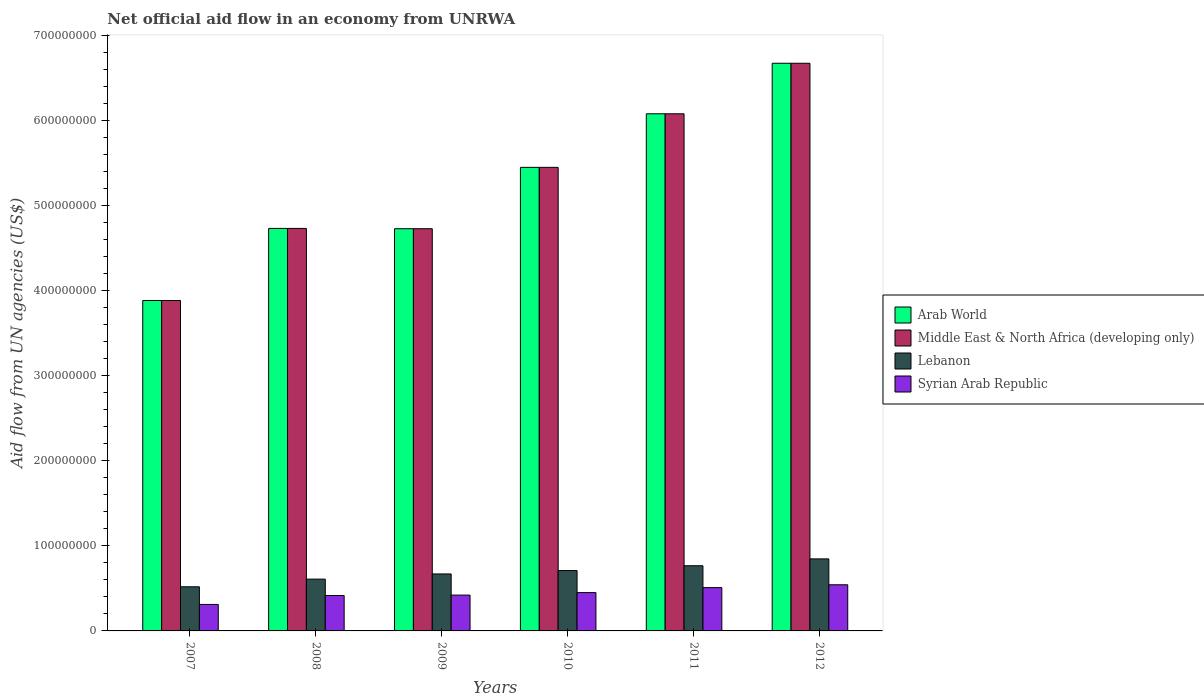How many different coloured bars are there?
Make the answer very short. 4. How many groups of bars are there?
Your answer should be compact. 6. Are the number of bars per tick equal to the number of legend labels?
Your answer should be very brief. Yes. Are the number of bars on each tick of the X-axis equal?
Provide a short and direct response. Yes. What is the label of the 3rd group of bars from the left?
Offer a terse response. 2009. In how many cases, is the number of bars for a given year not equal to the number of legend labels?
Provide a succinct answer. 0. What is the net official aid flow in Arab World in 2008?
Your response must be concise. 4.73e+08. Across all years, what is the maximum net official aid flow in Syrian Arab Republic?
Keep it short and to the point. 5.42e+07. Across all years, what is the minimum net official aid flow in Lebanon?
Your response must be concise. 5.19e+07. In which year was the net official aid flow in Syrian Arab Republic minimum?
Keep it short and to the point. 2007. What is the total net official aid flow in Arab World in the graph?
Ensure brevity in your answer.  3.15e+09. What is the difference between the net official aid flow in Arab World in 2009 and that in 2011?
Your answer should be very brief. -1.35e+08. What is the difference between the net official aid flow in Syrian Arab Republic in 2011 and the net official aid flow in Lebanon in 2008?
Offer a terse response. -1.00e+07. What is the average net official aid flow in Lebanon per year?
Provide a short and direct response. 6.87e+07. In the year 2007, what is the difference between the net official aid flow in Lebanon and net official aid flow in Arab World?
Give a very brief answer. -3.37e+08. In how many years, is the net official aid flow in Arab World greater than 340000000 US$?
Ensure brevity in your answer.  6. What is the ratio of the net official aid flow in Arab World in 2010 to that in 2012?
Provide a short and direct response. 0.82. Is the net official aid flow in Middle East & North Africa (developing only) in 2007 less than that in 2010?
Give a very brief answer. Yes. Is the difference between the net official aid flow in Lebanon in 2010 and 2011 greater than the difference between the net official aid flow in Arab World in 2010 and 2011?
Keep it short and to the point. Yes. What is the difference between the highest and the second highest net official aid flow in Syrian Arab Republic?
Give a very brief answer. 3.35e+06. What is the difference between the highest and the lowest net official aid flow in Middle East & North Africa (developing only)?
Ensure brevity in your answer.  2.79e+08. Is it the case that in every year, the sum of the net official aid flow in Arab World and net official aid flow in Lebanon is greater than the sum of net official aid flow in Middle East & North Africa (developing only) and net official aid flow in Syrian Arab Republic?
Offer a very short reply. No. What does the 3rd bar from the left in 2008 represents?
Your answer should be compact. Lebanon. What does the 3rd bar from the right in 2012 represents?
Ensure brevity in your answer.  Middle East & North Africa (developing only). How many bars are there?
Your answer should be compact. 24. Are all the bars in the graph horizontal?
Your response must be concise. No. How many years are there in the graph?
Provide a short and direct response. 6. Does the graph contain any zero values?
Your response must be concise. No. What is the title of the graph?
Ensure brevity in your answer.  Net official aid flow in an economy from UNRWA. Does "Cambodia" appear as one of the legend labels in the graph?
Your answer should be very brief. No. What is the label or title of the X-axis?
Your answer should be compact. Years. What is the label or title of the Y-axis?
Provide a succinct answer. Aid flow from UN agencies (US$). What is the Aid flow from UN agencies (US$) in Arab World in 2007?
Make the answer very short. 3.88e+08. What is the Aid flow from UN agencies (US$) of Middle East & North Africa (developing only) in 2007?
Ensure brevity in your answer.  3.88e+08. What is the Aid flow from UN agencies (US$) in Lebanon in 2007?
Your answer should be very brief. 5.19e+07. What is the Aid flow from UN agencies (US$) in Syrian Arab Republic in 2007?
Provide a short and direct response. 3.12e+07. What is the Aid flow from UN agencies (US$) of Arab World in 2008?
Provide a succinct answer. 4.73e+08. What is the Aid flow from UN agencies (US$) in Middle East & North Africa (developing only) in 2008?
Provide a short and direct response. 4.73e+08. What is the Aid flow from UN agencies (US$) of Lebanon in 2008?
Make the answer very short. 6.09e+07. What is the Aid flow from UN agencies (US$) of Syrian Arab Republic in 2008?
Ensure brevity in your answer.  4.16e+07. What is the Aid flow from UN agencies (US$) of Arab World in 2009?
Your response must be concise. 4.73e+08. What is the Aid flow from UN agencies (US$) of Middle East & North Africa (developing only) in 2009?
Your response must be concise. 4.73e+08. What is the Aid flow from UN agencies (US$) of Lebanon in 2009?
Keep it short and to the point. 6.70e+07. What is the Aid flow from UN agencies (US$) in Syrian Arab Republic in 2009?
Your answer should be compact. 4.21e+07. What is the Aid flow from UN agencies (US$) in Arab World in 2010?
Offer a terse response. 5.45e+08. What is the Aid flow from UN agencies (US$) in Middle East & North Africa (developing only) in 2010?
Your answer should be very brief. 5.45e+08. What is the Aid flow from UN agencies (US$) of Lebanon in 2010?
Offer a terse response. 7.10e+07. What is the Aid flow from UN agencies (US$) in Syrian Arab Republic in 2010?
Give a very brief answer. 4.50e+07. What is the Aid flow from UN agencies (US$) in Arab World in 2011?
Your answer should be very brief. 6.08e+08. What is the Aid flow from UN agencies (US$) in Middle East & North Africa (developing only) in 2011?
Keep it short and to the point. 6.08e+08. What is the Aid flow from UN agencies (US$) in Lebanon in 2011?
Your response must be concise. 7.66e+07. What is the Aid flow from UN agencies (US$) in Syrian Arab Republic in 2011?
Provide a succinct answer. 5.09e+07. What is the Aid flow from UN agencies (US$) in Arab World in 2012?
Keep it short and to the point. 6.67e+08. What is the Aid flow from UN agencies (US$) of Middle East & North Africa (developing only) in 2012?
Make the answer very short. 6.67e+08. What is the Aid flow from UN agencies (US$) of Lebanon in 2012?
Offer a very short reply. 8.47e+07. What is the Aid flow from UN agencies (US$) of Syrian Arab Republic in 2012?
Give a very brief answer. 5.42e+07. Across all years, what is the maximum Aid flow from UN agencies (US$) in Arab World?
Offer a terse response. 6.67e+08. Across all years, what is the maximum Aid flow from UN agencies (US$) of Middle East & North Africa (developing only)?
Your response must be concise. 6.67e+08. Across all years, what is the maximum Aid flow from UN agencies (US$) of Lebanon?
Give a very brief answer. 8.47e+07. Across all years, what is the maximum Aid flow from UN agencies (US$) of Syrian Arab Republic?
Make the answer very short. 5.42e+07. Across all years, what is the minimum Aid flow from UN agencies (US$) of Arab World?
Your answer should be compact. 3.88e+08. Across all years, what is the minimum Aid flow from UN agencies (US$) of Middle East & North Africa (developing only)?
Make the answer very short. 3.88e+08. Across all years, what is the minimum Aid flow from UN agencies (US$) in Lebanon?
Your response must be concise. 5.19e+07. Across all years, what is the minimum Aid flow from UN agencies (US$) of Syrian Arab Republic?
Make the answer very short. 3.12e+07. What is the total Aid flow from UN agencies (US$) of Arab World in the graph?
Ensure brevity in your answer.  3.15e+09. What is the total Aid flow from UN agencies (US$) in Middle East & North Africa (developing only) in the graph?
Offer a terse response. 3.15e+09. What is the total Aid flow from UN agencies (US$) of Lebanon in the graph?
Give a very brief answer. 4.12e+08. What is the total Aid flow from UN agencies (US$) of Syrian Arab Republic in the graph?
Offer a very short reply. 2.65e+08. What is the difference between the Aid flow from UN agencies (US$) of Arab World in 2007 and that in 2008?
Provide a succinct answer. -8.48e+07. What is the difference between the Aid flow from UN agencies (US$) in Middle East & North Africa (developing only) in 2007 and that in 2008?
Offer a terse response. -8.48e+07. What is the difference between the Aid flow from UN agencies (US$) in Lebanon in 2007 and that in 2008?
Your answer should be very brief. -9.01e+06. What is the difference between the Aid flow from UN agencies (US$) of Syrian Arab Republic in 2007 and that in 2008?
Offer a very short reply. -1.05e+07. What is the difference between the Aid flow from UN agencies (US$) of Arab World in 2007 and that in 2009?
Your response must be concise. -8.44e+07. What is the difference between the Aid flow from UN agencies (US$) of Middle East & North Africa (developing only) in 2007 and that in 2009?
Provide a short and direct response. -8.44e+07. What is the difference between the Aid flow from UN agencies (US$) of Lebanon in 2007 and that in 2009?
Your response must be concise. -1.51e+07. What is the difference between the Aid flow from UN agencies (US$) of Syrian Arab Republic in 2007 and that in 2009?
Provide a succinct answer. -1.10e+07. What is the difference between the Aid flow from UN agencies (US$) of Arab World in 2007 and that in 2010?
Ensure brevity in your answer.  -1.57e+08. What is the difference between the Aid flow from UN agencies (US$) in Middle East & North Africa (developing only) in 2007 and that in 2010?
Offer a terse response. -1.57e+08. What is the difference between the Aid flow from UN agencies (US$) of Lebanon in 2007 and that in 2010?
Keep it short and to the point. -1.91e+07. What is the difference between the Aid flow from UN agencies (US$) in Syrian Arab Republic in 2007 and that in 2010?
Make the answer very short. -1.39e+07. What is the difference between the Aid flow from UN agencies (US$) of Arab World in 2007 and that in 2011?
Provide a succinct answer. -2.20e+08. What is the difference between the Aid flow from UN agencies (US$) of Middle East & North Africa (developing only) in 2007 and that in 2011?
Your answer should be very brief. -2.20e+08. What is the difference between the Aid flow from UN agencies (US$) in Lebanon in 2007 and that in 2011?
Ensure brevity in your answer.  -2.47e+07. What is the difference between the Aid flow from UN agencies (US$) of Syrian Arab Republic in 2007 and that in 2011?
Your response must be concise. -1.98e+07. What is the difference between the Aid flow from UN agencies (US$) in Arab World in 2007 and that in 2012?
Provide a short and direct response. -2.79e+08. What is the difference between the Aid flow from UN agencies (US$) in Middle East & North Africa (developing only) in 2007 and that in 2012?
Provide a succinct answer. -2.79e+08. What is the difference between the Aid flow from UN agencies (US$) in Lebanon in 2007 and that in 2012?
Provide a succinct answer. -3.28e+07. What is the difference between the Aid flow from UN agencies (US$) in Syrian Arab Republic in 2007 and that in 2012?
Offer a very short reply. -2.31e+07. What is the difference between the Aid flow from UN agencies (US$) in Arab World in 2008 and that in 2009?
Offer a terse response. 3.60e+05. What is the difference between the Aid flow from UN agencies (US$) in Middle East & North Africa (developing only) in 2008 and that in 2009?
Your response must be concise. 3.60e+05. What is the difference between the Aid flow from UN agencies (US$) in Lebanon in 2008 and that in 2009?
Your answer should be very brief. -6.08e+06. What is the difference between the Aid flow from UN agencies (US$) in Syrian Arab Republic in 2008 and that in 2009?
Your response must be concise. -4.90e+05. What is the difference between the Aid flow from UN agencies (US$) in Arab World in 2008 and that in 2010?
Provide a succinct answer. -7.18e+07. What is the difference between the Aid flow from UN agencies (US$) in Middle East & North Africa (developing only) in 2008 and that in 2010?
Your response must be concise. -7.18e+07. What is the difference between the Aid flow from UN agencies (US$) of Lebanon in 2008 and that in 2010?
Keep it short and to the point. -1.01e+07. What is the difference between the Aid flow from UN agencies (US$) in Syrian Arab Republic in 2008 and that in 2010?
Offer a very short reply. -3.40e+06. What is the difference between the Aid flow from UN agencies (US$) in Arab World in 2008 and that in 2011?
Offer a very short reply. -1.35e+08. What is the difference between the Aid flow from UN agencies (US$) in Middle East & North Africa (developing only) in 2008 and that in 2011?
Make the answer very short. -1.35e+08. What is the difference between the Aid flow from UN agencies (US$) of Lebanon in 2008 and that in 2011?
Provide a succinct answer. -1.57e+07. What is the difference between the Aid flow from UN agencies (US$) of Syrian Arab Republic in 2008 and that in 2011?
Provide a short and direct response. -9.26e+06. What is the difference between the Aid flow from UN agencies (US$) in Arab World in 2008 and that in 2012?
Your answer should be very brief. -1.94e+08. What is the difference between the Aid flow from UN agencies (US$) of Middle East & North Africa (developing only) in 2008 and that in 2012?
Give a very brief answer. -1.94e+08. What is the difference between the Aid flow from UN agencies (US$) in Lebanon in 2008 and that in 2012?
Provide a succinct answer. -2.38e+07. What is the difference between the Aid flow from UN agencies (US$) in Syrian Arab Republic in 2008 and that in 2012?
Provide a succinct answer. -1.26e+07. What is the difference between the Aid flow from UN agencies (US$) of Arab World in 2009 and that in 2010?
Offer a very short reply. -7.21e+07. What is the difference between the Aid flow from UN agencies (US$) of Middle East & North Africa (developing only) in 2009 and that in 2010?
Ensure brevity in your answer.  -7.21e+07. What is the difference between the Aid flow from UN agencies (US$) in Lebanon in 2009 and that in 2010?
Your response must be concise. -3.99e+06. What is the difference between the Aid flow from UN agencies (US$) of Syrian Arab Republic in 2009 and that in 2010?
Provide a succinct answer. -2.91e+06. What is the difference between the Aid flow from UN agencies (US$) of Arab World in 2009 and that in 2011?
Make the answer very short. -1.35e+08. What is the difference between the Aid flow from UN agencies (US$) in Middle East & North Africa (developing only) in 2009 and that in 2011?
Give a very brief answer. -1.35e+08. What is the difference between the Aid flow from UN agencies (US$) in Lebanon in 2009 and that in 2011?
Your answer should be very brief. -9.64e+06. What is the difference between the Aid flow from UN agencies (US$) in Syrian Arab Republic in 2009 and that in 2011?
Keep it short and to the point. -8.77e+06. What is the difference between the Aid flow from UN agencies (US$) of Arab World in 2009 and that in 2012?
Your answer should be very brief. -1.95e+08. What is the difference between the Aid flow from UN agencies (US$) of Middle East & North Africa (developing only) in 2009 and that in 2012?
Provide a succinct answer. -1.95e+08. What is the difference between the Aid flow from UN agencies (US$) of Lebanon in 2009 and that in 2012?
Your answer should be compact. -1.77e+07. What is the difference between the Aid flow from UN agencies (US$) in Syrian Arab Republic in 2009 and that in 2012?
Ensure brevity in your answer.  -1.21e+07. What is the difference between the Aid flow from UN agencies (US$) in Arab World in 2010 and that in 2011?
Offer a terse response. -6.30e+07. What is the difference between the Aid flow from UN agencies (US$) of Middle East & North Africa (developing only) in 2010 and that in 2011?
Ensure brevity in your answer.  -6.30e+07. What is the difference between the Aid flow from UN agencies (US$) in Lebanon in 2010 and that in 2011?
Make the answer very short. -5.65e+06. What is the difference between the Aid flow from UN agencies (US$) of Syrian Arab Republic in 2010 and that in 2011?
Provide a succinct answer. -5.86e+06. What is the difference between the Aid flow from UN agencies (US$) in Arab World in 2010 and that in 2012?
Offer a very short reply. -1.22e+08. What is the difference between the Aid flow from UN agencies (US$) in Middle East & North Africa (developing only) in 2010 and that in 2012?
Ensure brevity in your answer.  -1.22e+08. What is the difference between the Aid flow from UN agencies (US$) of Lebanon in 2010 and that in 2012?
Your answer should be compact. -1.37e+07. What is the difference between the Aid flow from UN agencies (US$) of Syrian Arab Republic in 2010 and that in 2012?
Your answer should be compact. -9.21e+06. What is the difference between the Aid flow from UN agencies (US$) of Arab World in 2011 and that in 2012?
Offer a very short reply. -5.94e+07. What is the difference between the Aid flow from UN agencies (US$) of Middle East & North Africa (developing only) in 2011 and that in 2012?
Keep it short and to the point. -5.94e+07. What is the difference between the Aid flow from UN agencies (US$) in Lebanon in 2011 and that in 2012?
Provide a succinct answer. -8.07e+06. What is the difference between the Aid flow from UN agencies (US$) of Syrian Arab Republic in 2011 and that in 2012?
Your answer should be compact. -3.35e+06. What is the difference between the Aid flow from UN agencies (US$) of Arab World in 2007 and the Aid flow from UN agencies (US$) of Middle East & North Africa (developing only) in 2008?
Keep it short and to the point. -8.48e+07. What is the difference between the Aid flow from UN agencies (US$) in Arab World in 2007 and the Aid flow from UN agencies (US$) in Lebanon in 2008?
Your answer should be very brief. 3.28e+08. What is the difference between the Aid flow from UN agencies (US$) in Arab World in 2007 and the Aid flow from UN agencies (US$) in Syrian Arab Republic in 2008?
Provide a succinct answer. 3.47e+08. What is the difference between the Aid flow from UN agencies (US$) of Middle East & North Africa (developing only) in 2007 and the Aid flow from UN agencies (US$) of Lebanon in 2008?
Give a very brief answer. 3.28e+08. What is the difference between the Aid flow from UN agencies (US$) in Middle East & North Africa (developing only) in 2007 and the Aid flow from UN agencies (US$) in Syrian Arab Republic in 2008?
Provide a succinct answer. 3.47e+08. What is the difference between the Aid flow from UN agencies (US$) in Lebanon in 2007 and the Aid flow from UN agencies (US$) in Syrian Arab Republic in 2008?
Keep it short and to the point. 1.02e+07. What is the difference between the Aid flow from UN agencies (US$) in Arab World in 2007 and the Aid flow from UN agencies (US$) in Middle East & North Africa (developing only) in 2009?
Provide a short and direct response. -8.44e+07. What is the difference between the Aid flow from UN agencies (US$) of Arab World in 2007 and the Aid flow from UN agencies (US$) of Lebanon in 2009?
Your answer should be compact. 3.21e+08. What is the difference between the Aid flow from UN agencies (US$) in Arab World in 2007 and the Aid flow from UN agencies (US$) in Syrian Arab Republic in 2009?
Give a very brief answer. 3.46e+08. What is the difference between the Aid flow from UN agencies (US$) in Middle East & North Africa (developing only) in 2007 and the Aid flow from UN agencies (US$) in Lebanon in 2009?
Your answer should be very brief. 3.21e+08. What is the difference between the Aid flow from UN agencies (US$) of Middle East & North Africa (developing only) in 2007 and the Aid flow from UN agencies (US$) of Syrian Arab Republic in 2009?
Offer a very short reply. 3.46e+08. What is the difference between the Aid flow from UN agencies (US$) in Lebanon in 2007 and the Aid flow from UN agencies (US$) in Syrian Arab Republic in 2009?
Make the answer very short. 9.76e+06. What is the difference between the Aid flow from UN agencies (US$) in Arab World in 2007 and the Aid flow from UN agencies (US$) in Middle East & North Africa (developing only) in 2010?
Offer a very short reply. -1.57e+08. What is the difference between the Aid flow from UN agencies (US$) in Arab World in 2007 and the Aid flow from UN agencies (US$) in Lebanon in 2010?
Your answer should be very brief. 3.17e+08. What is the difference between the Aid flow from UN agencies (US$) of Arab World in 2007 and the Aid flow from UN agencies (US$) of Syrian Arab Republic in 2010?
Keep it short and to the point. 3.43e+08. What is the difference between the Aid flow from UN agencies (US$) in Middle East & North Africa (developing only) in 2007 and the Aid flow from UN agencies (US$) in Lebanon in 2010?
Ensure brevity in your answer.  3.17e+08. What is the difference between the Aid flow from UN agencies (US$) of Middle East & North Africa (developing only) in 2007 and the Aid flow from UN agencies (US$) of Syrian Arab Republic in 2010?
Offer a very short reply. 3.43e+08. What is the difference between the Aid flow from UN agencies (US$) of Lebanon in 2007 and the Aid flow from UN agencies (US$) of Syrian Arab Republic in 2010?
Your response must be concise. 6.85e+06. What is the difference between the Aid flow from UN agencies (US$) in Arab World in 2007 and the Aid flow from UN agencies (US$) in Middle East & North Africa (developing only) in 2011?
Offer a terse response. -2.20e+08. What is the difference between the Aid flow from UN agencies (US$) in Arab World in 2007 and the Aid flow from UN agencies (US$) in Lebanon in 2011?
Ensure brevity in your answer.  3.12e+08. What is the difference between the Aid flow from UN agencies (US$) of Arab World in 2007 and the Aid flow from UN agencies (US$) of Syrian Arab Republic in 2011?
Ensure brevity in your answer.  3.38e+08. What is the difference between the Aid flow from UN agencies (US$) of Middle East & North Africa (developing only) in 2007 and the Aid flow from UN agencies (US$) of Lebanon in 2011?
Keep it short and to the point. 3.12e+08. What is the difference between the Aid flow from UN agencies (US$) of Middle East & North Africa (developing only) in 2007 and the Aid flow from UN agencies (US$) of Syrian Arab Republic in 2011?
Your response must be concise. 3.38e+08. What is the difference between the Aid flow from UN agencies (US$) in Lebanon in 2007 and the Aid flow from UN agencies (US$) in Syrian Arab Republic in 2011?
Provide a short and direct response. 9.90e+05. What is the difference between the Aid flow from UN agencies (US$) in Arab World in 2007 and the Aid flow from UN agencies (US$) in Middle East & North Africa (developing only) in 2012?
Keep it short and to the point. -2.79e+08. What is the difference between the Aid flow from UN agencies (US$) of Arab World in 2007 and the Aid flow from UN agencies (US$) of Lebanon in 2012?
Your response must be concise. 3.04e+08. What is the difference between the Aid flow from UN agencies (US$) in Arab World in 2007 and the Aid flow from UN agencies (US$) in Syrian Arab Republic in 2012?
Keep it short and to the point. 3.34e+08. What is the difference between the Aid flow from UN agencies (US$) in Middle East & North Africa (developing only) in 2007 and the Aid flow from UN agencies (US$) in Lebanon in 2012?
Offer a terse response. 3.04e+08. What is the difference between the Aid flow from UN agencies (US$) of Middle East & North Africa (developing only) in 2007 and the Aid flow from UN agencies (US$) of Syrian Arab Republic in 2012?
Keep it short and to the point. 3.34e+08. What is the difference between the Aid flow from UN agencies (US$) of Lebanon in 2007 and the Aid flow from UN agencies (US$) of Syrian Arab Republic in 2012?
Make the answer very short. -2.36e+06. What is the difference between the Aid flow from UN agencies (US$) of Arab World in 2008 and the Aid flow from UN agencies (US$) of Middle East & North Africa (developing only) in 2009?
Give a very brief answer. 3.60e+05. What is the difference between the Aid flow from UN agencies (US$) of Arab World in 2008 and the Aid flow from UN agencies (US$) of Lebanon in 2009?
Your answer should be compact. 4.06e+08. What is the difference between the Aid flow from UN agencies (US$) of Arab World in 2008 and the Aid flow from UN agencies (US$) of Syrian Arab Republic in 2009?
Offer a terse response. 4.31e+08. What is the difference between the Aid flow from UN agencies (US$) in Middle East & North Africa (developing only) in 2008 and the Aid flow from UN agencies (US$) in Lebanon in 2009?
Your answer should be very brief. 4.06e+08. What is the difference between the Aid flow from UN agencies (US$) in Middle East & North Africa (developing only) in 2008 and the Aid flow from UN agencies (US$) in Syrian Arab Republic in 2009?
Provide a succinct answer. 4.31e+08. What is the difference between the Aid flow from UN agencies (US$) of Lebanon in 2008 and the Aid flow from UN agencies (US$) of Syrian Arab Republic in 2009?
Your answer should be very brief. 1.88e+07. What is the difference between the Aid flow from UN agencies (US$) of Arab World in 2008 and the Aid flow from UN agencies (US$) of Middle East & North Africa (developing only) in 2010?
Offer a terse response. -7.18e+07. What is the difference between the Aid flow from UN agencies (US$) in Arab World in 2008 and the Aid flow from UN agencies (US$) in Lebanon in 2010?
Offer a very short reply. 4.02e+08. What is the difference between the Aid flow from UN agencies (US$) of Arab World in 2008 and the Aid flow from UN agencies (US$) of Syrian Arab Republic in 2010?
Keep it short and to the point. 4.28e+08. What is the difference between the Aid flow from UN agencies (US$) in Middle East & North Africa (developing only) in 2008 and the Aid flow from UN agencies (US$) in Lebanon in 2010?
Your answer should be very brief. 4.02e+08. What is the difference between the Aid flow from UN agencies (US$) of Middle East & North Africa (developing only) in 2008 and the Aid flow from UN agencies (US$) of Syrian Arab Republic in 2010?
Keep it short and to the point. 4.28e+08. What is the difference between the Aid flow from UN agencies (US$) of Lebanon in 2008 and the Aid flow from UN agencies (US$) of Syrian Arab Republic in 2010?
Ensure brevity in your answer.  1.59e+07. What is the difference between the Aid flow from UN agencies (US$) of Arab World in 2008 and the Aid flow from UN agencies (US$) of Middle East & North Africa (developing only) in 2011?
Your response must be concise. -1.35e+08. What is the difference between the Aid flow from UN agencies (US$) in Arab World in 2008 and the Aid flow from UN agencies (US$) in Lebanon in 2011?
Give a very brief answer. 3.97e+08. What is the difference between the Aid flow from UN agencies (US$) in Arab World in 2008 and the Aid flow from UN agencies (US$) in Syrian Arab Republic in 2011?
Give a very brief answer. 4.22e+08. What is the difference between the Aid flow from UN agencies (US$) of Middle East & North Africa (developing only) in 2008 and the Aid flow from UN agencies (US$) of Lebanon in 2011?
Offer a very short reply. 3.97e+08. What is the difference between the Aid flow from UN agencies (US$) of Middle East & North Africa (developing only) in 2008 and the Aid flow from UN agencies (US$) of Syrian Arab Republic in 2011?
Offer a terse response. 4.22e+08. What is the difference between the Aid flow from UN agencies (US$) of Lebanon in 2008 and the Aid flow from UN agencies (US$) of Syrian Arab Republic in 2011?
Keep it short and to the point. 1.00e+07. What is the difference between the Aid flow from UN agencies (US$) in Arab World in 2008 and the Aid flow from UN agencies (US$) in Middle East & North Africa (developing only) in 2012?
Provide a short and direct response. -1.94e+08. What is the difference between the Aid flow from UN agencies (US$) of Arab World in 2008 and the Aid flow from UN agencies (US$) of Lebanon in 2012?
Make the answer very short. 3.88e+08. What is the difference between the Aid flow from UN agencies (US$) in Arab World in 2008 and the Aid flow from UN agencies (US$) in Syrian Arab Republic in 2012?
Provide a succinct answer. 4.19e+08. What is the difference between the Aid flow from UN agencies (US$) of Middle East & North Africa (developing only) in 2008 and the Aid flow from UN agencies (US$) of Lebanon in 2012?
Give a very brief answer. 3.88e+08. What is the difference between the Aid flow from UN agencies (US$) in Middle East & North Africa (developing only) in 2008 and the Aid flow from UN agencies (US$) in Syrian Arab Republic in 2012?
Offer a very short reply. 4.19e+08. What is the difference between the Aid flow from UN agencies (US$) of Lebanon in 2008 and the Aid flow from UN agencies (US$) of Syrian Arab Republic in 2012?
Give a very brief answer. 6.65e+06. What is the difference between the Aid flow from UN agencies (US$) of Arab World in 2009 and the Aid flow from UN agencies (US$) of Middle East & North Africa (developing only) in 2010?
Offer a very short reply. -7.21e+07. What is the difference between the Aid flow from UN agencies (US$) of Arab World in 2009 and the Aid flow from UN agencies (US$) of Lebanon in 2010?
Offer a very short reply. 4.02e+08. What is the difference between the Aid flow from UN agencies (US$) in Arab World in 2009 and the Aid flow from UN agencies (US$) in Syrian Arab Republic in 2010?
Ensure brevity in your answer.  4.28e+08. What is the difference between the Aid flow from UN agencies (US$) of Middle East & North Africa (developing only) in 2009 and the Aid flow from UN agencies (US$) of Lebanon in 2010?
Keep it short and to the point. 4.02e+08. What is the difference between the Aid flow from UN agencies (US$) in Middle East & North Africa (developing only) in 2009 and the Aid flow from UN agencies (US$) in Syrian Arab Republic in 2010?
Your response must be concise. 4.28e+08. What is the difference between the Aid flow from UN agencies (US$) of Lebanon in 2009 and the Aid flow from UN agencies (US$) of Syrian Arab Republic in 2010?
Your answer should be very brief. 2.19e+07. What is the difference between the Aid flow from UN agencies (US$) of Arab World in 2009 and the Aid flow from UN agencies (US$) of Middle East & North Africa (developing only) in 2011?
Offer a very short reply. -1.35e+08. What is the difference between the Aid flow from UN agencies (US$) in Arab World in 2009 and the Aid flow from UN agencies (US$) in Lebanon in 2011?
Provide a succinct answer. 3.96e+08. What is the difference between the Aid flow from UN agencies (US$) in Arab World in 2009 and the Aid flow from UN agencies (US$) in Syrian Arab Republic in 2011?
Offer a very short reply. 4.22e+08. What is the difference between the Aid flow from UN agencies (US$) in Middle East & North Africa (developing only) in 2009 and the Aid flow from UN agencies (US$) in Lebanon in 2011?
Your response must be concise. 3.96e+08. What is the difference between the Aid flow from UN agencies (US$) in Middle East & North Africa (developing only) in 2009 and the Aid flow from UN agencies (US$) in Syrian Arab Republic in 2011?
Provide a succinct answer. 4.22e+08. What is the difference between the Aid flow from UN agencies (US$) of Lebanon in 2009 and the Aid flow from UN agencies (US$) of Syrian Arab Republic in 2011?
Keep it short and to the point. 1.61e+07. What is the difference between the Aid flow from UN agencies (US$) in Arab World in 2009 and the Aid flow from UN agencies (US$) in Middle East & North Africa (developing only) in 2012?
Your answer should be compact. -1.95e+08. What is the difference between the Aid flow from UN agencies (US$) in Arab World in 2009 and the Aid flow from UN agencies (US$) in Lebanon in 2012?
Provide a short and direct response. 3.88e+08. What is the difference between the Aid flow from UN agencies (US$) of Arab World in 2009 and the Aid flow from UN agencies (US$) of Syrian Arab Republic in 2012?
Provide a succinct answer. 4.19e+08. What is the difference between the Aid flow from UN agencies (US$) of Middle East & North Africa (developing only) in 2009 and the Aid flow from UN agencies (US$) of Lebanon in 2012?
Ensure brevity in your answer.  3.88e+08. What is the difference between the Aid flow from UN agencies (US$) in Middle East & North Africa (developing only) in 2009 and the Aid flow from UN agencies (US$) in Syrian Arab Republic in 2012?
Provide a short and direct response. 4.19e+08. What is the difference between the Aid flow from UN agencies (US$) in Lebanon in 2009 and the Aid flow from UN agencies (US$) in Syrian Arab Republic in 2012?
Offer a terse response. 1.27e+07. What is the difference between the Aid flow from UN agencies (US$) in Arab World in 2010 and the Aid flow from UN agencies (US$) in Middle East & North Africa (developing only) in 2011?
Offer a terse response. -6.30e+07. What is the difference between the Aid flow from UN agencies (US$) in Arab World in 2010 and the Aid flow from UN agencies (US$) in Lebanon in 2011?
Offer a terse response. 4.68e+08. What is the difference between the Aid flow from UN agencies (US$) in Arab World in 2010 and the Aid flow from UN agencies (US$) in Syrian Arab Republic in 2011?
Your answer should be very brief. 4.94e+08. What is the difference between the Aid flow from UN agencies (US$) in Middle East & North Africa (developing only) in 2010 and the Aid flow from UN agencies (US$) in Lebanon in 2011?
Provide a succinct answer. 4.68e+08. What is the difference between the Aid flow from UN agencies (US$) in Middle East & North Africa (developing only) in 2010 and the Aid flow from UN agencies (US$) in Syrian Arab Republic in 2011?
Offer a terse response. 4.94e+08. What is the difference between the Aid flow from UN agencies (US$) of Lebanon in 2010 and the Aid flow from UN agencies (US$) of Syrian Arab Republic in 2011?
Keep it short and to the point. 2.01e+07. What is the difference between the Aid flow from UN agencies (US$) in Arab World in 2010 and the Aid flow from UN agencies (US$) in Middle East & North Africa (developing only) in 2012?
Keep it short and to the point. -1.22e+08. What is the difference between the Aid flow from UN agencies (US$) of Arab World in 2010 and the Aid flow from UN agencies (US$) of Lebanon in 2012?
Your response must be concise. 4.60e+08. What is the difference between the Aid flow from UN agencies (US$) in Arab World in 2010 and the Aid flow from UN agencies (US$) in Syrian Arab Republic in 2012?
Keep it short and to the point. 4.91e+08. What is the difference between the Aid flow from UN agencies (US$) of Middle East & North Africa (developing only) in 2010 and the Aid flow from UN agencies (US$) of Lebanon in 2012?
Keep it short and to the point. 4.60e+08. What is the difference between the Aid flow from UN agencies (US$) in Middle East & North Africa (developing only) in 2010 and the Aid flow from UN agencies (US$) in Syrian Arab Republic in 2012?
Keep it short and to the point. 4.91e+08. What is the difference between the Aid flow from UN agencies (US$) in Lebanon in 2010 and the Aid flow from UN agencies (US$) in Syrian Arab Republic in 2012?
Give a very brief answer. 1.67e+07. What is the difference between the Aid flow from UN agencies (US$) of Arab World in 2011 and the Aid flow from UN agencies (US$) of Middle East & North Africa (developing only) in 2012?
Your answer should be compact. -5.94e+07. What is the difference between the Aid flow from UN agencies (US$) in Arab World in 2011 and the Aid flow from UN agencies (US$) in Lebanon in 2012?
Your answer should be compact. 5.23e+08. What is the difference between the Aid flow from UN agencies (US$) in Arab World in 2011 and the Aid flow from UN agencies (US$) in Syrian Arab Republic in 2012?
Offer a terse response. 5.54e+08. What is the difference between the Aid flow from UN agencies (US$) in Middle East & North Africa (developing only) in 2011 and the Aid flow from UN agencies (US$) in Lebanon in 2012?
Provide a succinct answer. 5.23e+08. What is the difference between the Aid flow from UN agencies (US$) of Middle East & North Africa (developing only) in 2011 and the Aid flow from UN agencies (US$) of Syrian Arab Republic in 2012?
Ensure brevity in your answer.  5.54e+08. What is the difference between the Aid flow from UN agencies (US$) in Lebanon in 2011 and the Aid flow from UN agencies (US$) in Syrian Arab Republic in 2012?
Your answer should be very brief. 2.24e+07. What is the average Aid flow from UN agencies (US$) in Arab World per year?
Give a very brief answer. 5.26e+08. What is the average Aid flow from UN agencies (US$) of Middle East & North Africa (developing only) per year?
Your response must be concise. 5.26e+08. What is the average Aid flow from UN agencies (US$) in Lebanon per year?
Offer a very short reply. 6.87e+07. What is the average Aid flow from UN agencies (US$) of Syrian Arab Republic per year?
Your answer should be very brief. 4.42e+07. In the year 2007, what is the difference between the Aid flow from UN agencies (US$) of Arab World and Aid flow from UN agencies (US$) of Middle East & North Africa (developing only)?
Offer a terse response. 0. In the year 2007, what is the difference between the Aid flow from UN agencies (US$) of Arab World and Aid flow from UN agencies (US$) of Lebanon?
Give a very brief answer. 3.37e+08. In the year 2007, what is the difference between the Aid flow from UN agencies (US$) of Arab World and Aid flow from UN agencies (US$) of Syrian Arab Republic?
Your answer should be very brief. 3.57e+08. In the year 2007, what is the difference between the Aid flow from UN agencies (US$) in Middle East & North Africa (developing only) and Aid flow from UN agencies (US$) in Lebanon?
Offer a very short reply. 3.37e+08. In the year 2007, what is the difference between the Aid flow from UN agencies (US$) in Middle East & North Africa (developing only) and Aid flow from UN agencies (US$) in Syrian Arab Republic?
Make the answer very short. 3.57e+08. In the year 2007, what is the difference between the Aid flow from UN agencies (US$) in Lebanon and Aid flow from UN agencies (US$) in Syrian Arab Republic?
Give a very brief answer. 2.07e+07. In the year 2008, what is the difference between the Aid flow from UN agencies (US$) in Arab World and Aid flow from UN agencies (US$) in Middle East & North Africa (developing only)?
Keep it short and to the point. 0. In the year 2008, what is the difference between the Aid flow from UN agencies (US$) of Arab World and Aid flow from UN agencies (US$) of Lebanon?
Offer a terse response. 4.12e+08. In the year 2008, what is the difference between the Aid flow from UN agencies (US$) in Arab World and Aid flow from UN agencies (US$) in Syrian Arab Republic?
Your answer should be compact. 4.32e+08. In the year 2008, what is the difference between the Aid flow from UN agencies (US$) in Middle East & North Africa (developing only) and Aid flow from UN agencies (US$) in Lebanon?
Provide a short and direct response. 4.12e+08. In the year 2008, what is the difference between the Aid flow from UN agencies (US$) in Middle East & North Africa (developing only) and Aid flow from UN agencies (US$) in Syrian Arab Republic?
Keep it short and to the point. 4.32e+08. In the year 2008, what is the difference between the Aid flow from UN agencies (US$) in Lebanon and Aid flow from UN agencies (US$) in Syrian Arab Republic?
Your response must be concise. 1.93e+07. In the year 2009, what is the difference between the Aid flow from UN agencies (US$) of Arab World and Aid flow from UN agencies (US$) of Middle East & North Africa (developing only)?
Offer a very short reply. 0. In the year 2009, what is the difference between the Aid flow from UN agencies (US$) in Arab World and Aid flow from UN agencies (US$) in Lebanon?
Offer a terse response. 4.06e+08. In the year 2009, what is the difference between the Aid flow from UN agencies (US$) in Arab World and Aid flow from UN agencies (US$) in Syrian Arab Republic?
Offer a terse response. 4.31e+08. In the year 2009, what is the difference between the Aid flow from UN agencies (US$) of Middle East & North Africa (developing only) and Aid flow from UN agencies (US$) of Lebanon?
Provide a short and direct response. 4.06e+08. In the year 2009, what is the difference between the Aid flow from UN agencies (US$) in Middle East & North Africa (developing only) and Aid flow from UN agencies (US$) in Syrian Arab Republic?
Your response must be concise. 4.31e+08. In the year 2009, what is the difference between the Aid flow from UN agencies (US$) in Lebanon and Aid flow from UN agencies (US$) in Syrian Arab Republic?
Provide a short and direct response. 2.48e+07. In the year 2010, what is the difference between the Aid flow from UN agencies (US$) in Arab World and Aid flow from UN agencies (US$) in Middle East & North Africa (developing only)?
Offer a terse response. 0. In the year 2010, what is the difference between the Aid flow from UN agencies (US$) in Arab World and Aid flow from UN agencies (US$) in Lebanon?
Your answer should be very brief. 4.74e+08. In the year 2010, what is the difference between the Aid flow from UN agencies (US$) of Arab World and Aid flow from UN agencies (US$) of Syrian Arab Republic?
Your answer should be very brief. 5.00e+08. In the year 2010, what is the difference between the Aid flow from UN agencies (US$) of Middle East & North Africa (developing only) and Aid flow from UN agencies (US$) of Lebanon?
Offer a terse response. 4.74e+08. In the year 2010, what is the difference between the Aid flow from UN agencies (US$) in Middle East & North Africa (developing only) and Aid flow from UN agencies (US$) in Syrian Arab Republic?
Keep it short and to the point. 5.00e+08. In the year 2010, what is the difference between the Aid flow from UN agencies (US$) of Lebanon and Aid flow from UN agencies (US$) of Syrian Arab Republic?
Your answer should be very brief. 2.59e+07. In the year 2011, what is the difference between the Aid flow from UN agencies (US$) in Arab World and Aid flow from UN agencies (US$) in Lebanon?
Your answer should be very brief. 5.31e+08. In the year 2011, what is the difference between the Aid flow from UN agencies (US$) in Arab World and Aid flow from UN agencies (US$) in Syrian Arab Republic?
Offer a terse response. 5.57e+08. In the year 2011, what is the difference between the Aid flow from UN agencies (US$) of Middle East & North Africa (developing only) and Aid flow from UN agencies (US$) of Lebanon?
Ensure brevity in your answer.  5.31e+08. In the year 2011, what is the difference between the Aid flow from UN agencies (US$) of Middle East & North Africa (developing only) and Aid flow from UN agencies (US$) of Syrian Arab Republic?
Provide a succinct answer. 5.57e+08. In the year 2011, what is the difference between the Aid flow from UN agencies (US$) of Lebanon and Aid flow from UN agencies (US$) of Syrian Arab Republic?
Ensure brevity in your answer.  2.57e+07. In the year 2012, what is the difference between the Aid flow from UN agencies (US$) of Arab World and Aid flow from UN agencies (US$) of Middle East & North Africa (developing only)?
Offer a terse response. 0. In the year 2012, what is the difference between the Aid flow from UN agencies (US$) in Arab World and Aid flow from UN agencies (US$) in Lebanon?
Offer a terse response. 5.83e+08. In the year 2012, what is the difference between the Aid flow from UN agencies (US$) of Arab World and Aid flow from UN agencies (US$) of Syrian Arab Republic?
Your response must be concise. 6.13e+08. In the year 2012, what is the difference between the Aid flow from UN agencies (US$) of Middle East & North Africa (developing only) and Aid flow from UN agencies (US$) of Lebanon?
Provide a short and direct response. 5.83e+08. In the year 2012, what is the difference between the Aid flow from UN agencies (US$) in Middle East & North Africa (developing only) and Aid flow from UN agencies (US$) in Syrian Arab Republic?
Offer a very short reply. 6.13e+08. In the year 2012, what is the difference between the Aid flow from UN agencies (US$) of Lebanon and Aid flow from UN agencies (US$) of Syrian Arab Republic?
Offer a very short reply. 3.04e+07. What is the ratio of the Aid flow from UN agencies (US$) in Arab World in 2007 to that in 2008?
Offer a very short reply. 0.82. What is the ratio of the Aid flow from UN agencies (US$) in Middle East & North Africa (developing only) in 2007 to that in 2008?
Offer a terse response. 0.82. What is the ratio of the Aid flow from UN agencies (US$) in Lebanon in 2007 to that in 2008?
Provide a short and direct response. 0.85. What is the ratio of the Aid flow from UN agencies (US$) of Syrian Arab Republic in 2007 to that in 2008?
Your response must be concise. 0.75. What is the ratio of the Aid flow from UN agencies (US$) of Arab World in 2007 to that in 2009?
Offer a very short reply. 0.82. What is the ratio of the Aid flow from UN agencies (US$) of Middle East & North Africa (developing only) in 2007 to that in 2009?
Keep it short and to the point. 0.82. What is the ratio of the Aid flow from UN agencies (US$) in Lebanon in 2007 to that in 2009?
Ensure brevity in your answer.  0.77. What is the ratio of the Aid flow from UN agencies (US$) in Syrian Arab Republic in 2007 to that in 2009?
Ensure brevity in your answer.  0.74. What is the ratio of the Aid flow from UN agencies (US$) of Arab World in 2007 to that in 2010?
Give a very brief answer. 0.71. What is the ratio of the Aid flow from UN agencies (US$) of Middle East & North Africa (developing only) in 2007 to that in 2010?
Provide a short and direct response. 0.71. What is the ratio of the Aid flow from UN agencies (US$) of Lebanon in 2007 to that in 2010?
Provide a short and direct response. 0.73. What is the ratio of the Aid flow from UN agencies (US$) in Syrian Arab Republic in 2007 to that in 2010?
Your answer should be very brief. 0.69. What is the ratio of the Aid flow from UN agencies (US$) of Arab World in 2007 to that in 2011?
Give a very brief answer. 0.64. What is the ratio of the Aid flow from UN agencies (US$) in Middle East & North Africa (developing only) in 2007 to that in 2011?
Your answer should be very brief. 0.64. What is the ratio of the Aid flow from UN agencies (US$) of Lebanon in 2007 to that in 2011?
Your response must be concise. 0.68. What is the ratio of the Aid flow from UN agencies (US$) of Syrian Arab Republic in 2007 to that in 2011?
Provide a succinct answer. 0.61. What is the ratio of the Aid flow from UN agencies (US$) in Arab World in 2007 to that in 2012?
Keep it short and to the point. 0.58. What is the ratio of the Aid flow from UN agencies (US$) of Middle East & North Africa (developing only) in 2007 to that in 2012?
Provide a succinct answer. 0.58. What is the ratio of the Aid flow from UN agencies (US$) in Lebanon in 2007 to that in 2012?
Make the answer very short. 0.61. What is the ratio of the Aid flow from UN agencies (US$) in Syrian Arab Republic in 2007 to that in 2012?
Your response must be concise. 0.57. What is the ratio of the Aid flow from UN agencies (US$) of Lebanon in 2008 to that in 2009?
Offer a very short reply. 0.91. What is the ratio of the Aid flow from UN agencies (US$) of Syrian Arab Republic in 2008 to that in 2009?
Your response must be concise. 0.99. What is the ratio of the Aid flow from UN agencies (US$) of Arab World in 2008 to that in 2010?
Offer a very short reply. 0.87. What is the ratio of the Aid flow from UN agencies (US$) in Middle East & North Africa (developing only) in 2008 to that in 2010?
Your answer should be very brief. 0.87. What is the ratio of the Aid flow from UN agencies (US$) in Lebanon in 2008 to that in 2010?
Your answer should be very brief. 0.86. What is the ratio of the Aid flow from UN agencies (US$) of Syrian Arab Republic in 2008 to that in 2010?
Make the answer very short. 0.92. What is the ratio of the Aid flow from UN agencies (US$) in Arab World in 2008 to that in 2011?
Give a very brief answer. 0.78. What is the ratio of the Aid flow from UN agencies (US$) of Middle East & North Africa (developing only) in 2008 to that in 2011?
Your answer should be compact. 0.78. What is the ratio of the Aid flow from UN agencies (US$) of Lebanon in 2008 to that in 2011?
Provide a short and direct response. 0.79. What is the ratio of the Aid flow from UN agencies (US$) in Syrian Arab Republic in 2008 to that in 2011?
Your response must be concise. 0.82. What is the ratio of the Aid flow from UN agencies (US$) of Arab World in 2008 to that in 2012?
Provide a short and direct response. 0.71. What is the ratio of the Aid flow from UN agencies (US$) of Middle East & North Africa (developing only) in 2008 to that in 2012?
Your answer should be very brief. 0.71. What is the ratio of the Aid flow from UN agencies (US$) in Lebanon in 2008 to that in 2012?
Provide a succinct answer. 0.72. What is the ratio of the Aid flow from UN agencies (US$) in Syrian Arab Republic in 2008 to that in 2012?
Offer a very short reply. 0.77. What is the ratio of the Aid flow from UN agencies (US$) in Arab World in 2009 to that in 2010?
Offer a very short reply. 0.87. What is the ratio of the Aid flow from UN agencies (US$) of Middle East & North Africa (developing only) in 2009 to that in 2010?
Make the answer very short. 0.87. What is the ratio of the Aid flow from UN agencies (US$) of Lebanon in 2009 to that in 2010?
Your answer should be compact. 0.94. What is the ratio of the Aid flow from UN agencies (US$) of Syrian Arab Republic in 2009 to that in 2010?
Your response must be concise. 0.94. What is the ratio of the Aid flow from UN agencies (US$) of Lebanon in 2009 to that in 2011?
Keep it short and to the point. 0.87. What is the ratio of the Aid flow from UN agencies (US$) of Syrian Arab Republic in 2009 to that in 2011?
Ensure brevity in your answer.  0.83. What is the ratio of the Aid flow from UN agencies (US$) of Arab World in 2009 to that in 2012?
Keep it short and to the point. 0.71. What is the ratio of the Aid flow from UN agencies (US$) in Middle East & North Africa (developing only) in 2009 to that in 2012?
Provide a succinct answer. 0.71. What is the ratio of the Aid flow from UN agencies (US$) of Lebanon in 2009 to that in 2012?
Keep it short and to the point. 0.79. What is the ratio of the Aid flow from UN agencies (US$) in Syrian Arab Republic in 2009 to that in 2012?
Your answer should be compact. 0.78. What is the ratio of the Aid flow from UN agencies (US$) in Arab World in 2010 to that in 2011?
Keep it short and to the point. 0.9. What is the ratio of the Aid flow from UN agencies (US$) in Middle East & North Africa (developing only) in 2010 to that in 2011?
Make the answer very short. 0.9. What is the ratio of the Aid flow from UN agencies (US$) in Lebanon in 2010 to that in 2011?
Make the answer very short. 0.93. What is the ratio of the Aid flow from UN agencies (US$) in Syrian Arab Republic in 2010 to that in 2011?
Your response must be concise. 0.88. What is the ratio of the Aid flow from UN agencies (US$) in Arab World in 2010 to that in 2012?
Offer a terse response. 0.82. What is the ratio of the Aid flow from UN agencies (US$) in Middle East & North Africa (developing only) in 2010 to that in 2012?
Your answer should be compact. 0.82. What is the ratio of the Aid flow from UN agencies (US$) in Lebanon in 2010 to that in 2012?
Keep it short and to the point. 0.84. What is the ratio of the Aid flow from UN agencies (US$) in Syrian Arab Republic in 2010 to that in 2012?
Make the answer very short. 0.83. What is the ratio of the Aid flow from UN agencies (US$) of Arab World in 2011 to that in 2012?
Give a very brief answer. 0.91. What is the ratio of the Aid flow from UN agencies (US$) in Middle East & North Africa (developing only) in 2011 to that in 2012?
Give a very brief answer. 0.91. What is the ratio of the Aid flow from UN agencies (US$) in Lebanon in 2011 to that in 2012?
Give a very brief answer. 0.9. What is the ratio of the Aid flow from UN agencies (US$) of Syrian Arab Republic in 2011 to that in 2012?
Give a very brief answer. 0.94. What is the difference between the highest and the second highest Aid flow from UN agencies (US$) of Arab World?
Make the answer very short. 5.94e+07. What is the difference between the highest and the second highest Aid flow from UN agencies (US$) in Middle East & North Africa (developing only)?
Give a very brief answer. 5.94e+07. What is the difference between the highest and the second highest Aid flow from UN agencies (US$) of Lebanon?
Provide a succinct answer. 8.07e+06. What is the difference between the highest and the second highest Aid flow from UN agencies (US$) in Syrian Arab Republic?
Make the answer very short. 3.35e+06. What is the difference between the highest and the lowest Aid flow from UN agencies (US$) in Arab World?
Your answer should be very brief. 2.79e+08. What is the difference between the highest and the lowest Aid flow from UN agencies (US$) in Middle East & North Africa (developing only)?
Provide a succinct answer. 2.79e+08. What is the difference between the highest and the lowest Aid flow from UN agencies (US$) in Lebanon?
Ensure brevity in your answer.  3.28e+07. What is the difference between the highest and the lowest Aid flow from UN agencies (US$) in Syrian Arab Republic?
Your answer should be compact. 2.31e+07. 